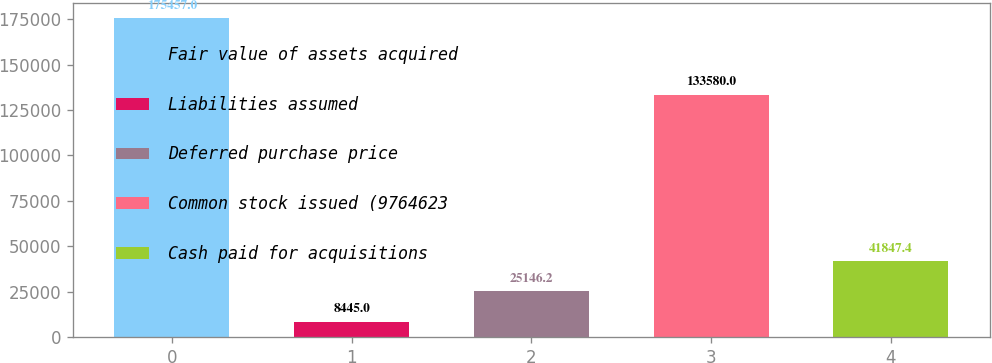<chart> <loc_0><loc_0><loc_500><loc_500><bar_chart><fcel>Fair value of assets acquired<fcel>Liabilities assumed<fcel>Deferred purchase price<fcel>Common stock issued (9764623<fcel>Cash paid for acquisitions<nl><fcel>175457<fcel>8445<fcel>25146.2<fcel>133580<fcel>41847.4<nl></chart> 